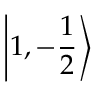<formula> <loc_0><loc_0><loc_500><loc_500>\left | 1 , - { \frac { 1 } { 2 } } \right \rangle</formula> 